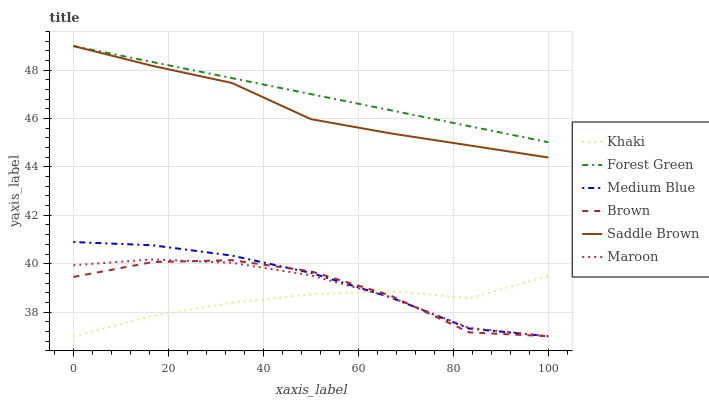Does Medium Blue have the minimum area under the curve?
Answer yes or no. No. Does Medium Blue have the maximum area under the curve?
Answer yes or no. No. Is Khaki the smoothest?
Answer yes or no. No. Is Khaki the roughest?
Answer yes or no. No. Does Forest Green have the lowest value?
Answer yes or no. No. Does Medium Blue have the highest value?
Answer yes or no. No. Is Medium Blue less than Forest Green?
Answer yes or no. Yes. Is Saddle Brown greater than Medium Blue?
Answer yes or no. Yes. Does Medium Blue intersect Forest Green?
Answer yes or no. No. 